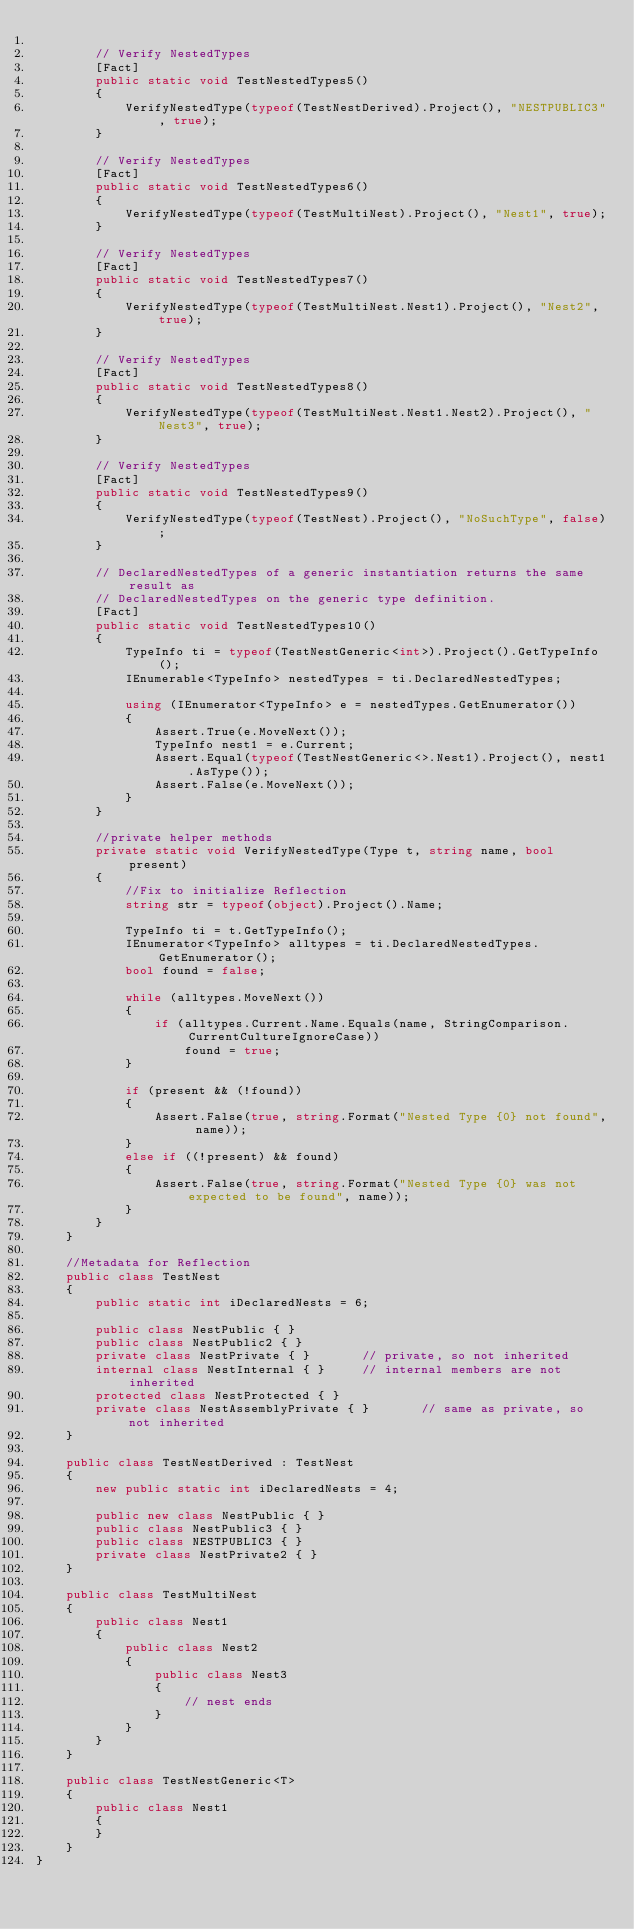Convert code to text. <code><loc_0><loc_0><loc_500><loc_500><_C#_>
        // Verify NestedTypes
        [Fact]
        public static void TestNestedTypes5()
        {
            VerifyNestedType(typeof(TestNestDerived).Project(), "NESTPUBLIC3", true);
        }

        // Verify NestedTypes
        [Fact]
        public static void TestNestedTypes6()
        {
            VerifyNestedType(typeof(TestMultiNest).Project(), "Nest1", true);
        }

        // Verify NestedTypes
        [Fact]
        public static void TestNestedTypes7()
        {
            VerifyNestedType(typeof(TestMultiNest.Nest1).Project(), "Nest2", true);
        }

        // Verify NestedTypes
        [Fact]
        public static void TestNestedTypes8()
        {
            VerifyNestedType(typeof(TestMultiNest.Nest1.Nest2).Project(), "Nest3", true);
        }

        // Verify NestedTypes
        [Fact]
        public static void TestNestedTypes9()
        {
            VerifyNestedType(typeof(TestNest).Project(), "NoSuchType", false);
        }

        // DeclaredNestedTypes of a generic instantiation returns the same result as
        // DeclaredNestedTypes on the generic type definition.
        [Fact]
        public static void TestNestedTypes10()
        {
            TypeInfo ti = typeof(TestNestGeneric<int>).Project().GetTypeInfo();
            IEnumerable<TypeInfo> nestedTypes = ti.DeclaredNestedTypes;

            using (IEnumerator<TypeInfo> e = nestedTypes.GetEnumerator())
            {
                Assert.True(e.MoveNext());
                TypeInfo nest1 = e.Current;
                Assert.Equal(typeof(TestNestGeneric<>.Nest1).Project(), nest1.AsType());
                Assert.False(e.MoveNext());
            }
        }

        //private helper methods
        private static void VerifyNestedType(Type t, string name, bool present)
        {
            //Fix to initialize Reflection
            string str = typeof(object).Project().Name;

            TypeInfo ti = t.GetTypeInfo();
            IEnumerator<TypeInfo> alltypes = ti.DeclaredNestedTypes.GetEnumerator();
            bool found = false;

            while (alltypes.MoveNext())
            {
                if (alltypes.Current.Name.Equals(name, StringComparison.CurrentCultureIgnoreCase))
                    found = true;
            }

            if (present && (!found))
            {
                Assert.False(true, string.Format("Nested Type {0} not found", name));
            }
            else if ((!present) && found)
            {
                Assert.False(true, string.Format("Nested Type {0} was not expected to be found", name));
            }
        }
    }

    //Metadata for Reflection
    public class TestNest
    {
        public static int iDeclaredNests = 6;

        public class NestPublic { }
        public class NestPublic2 { }
        private class NestPrivate { }		// private, so not inherited
        internal class NestInternal { }		// internal members are not inherited
        protected class NestProtected { }
        private class NestAssemblyPrivate { }		// same as private, so not inherited
    }

    public class TestNestDerived : TestNest
    {
        new public static int iDeclaredNests = 4;

        public new class NestPublic { }
        public class NestPublic3 { }
        public class NESTPUBLIC3 { }
        private class NestPrivate2 { }
    }

    public class TestMultiNest
    {
        public class Nest1
        {
            public class Nest2
            {
                public class Nest3
                {
                    // nest ends
                }
            }
        }
    }

    public class TestNestGeneric<T>
    {
        public class Nest1
        {
        }
    }
}
</code> 